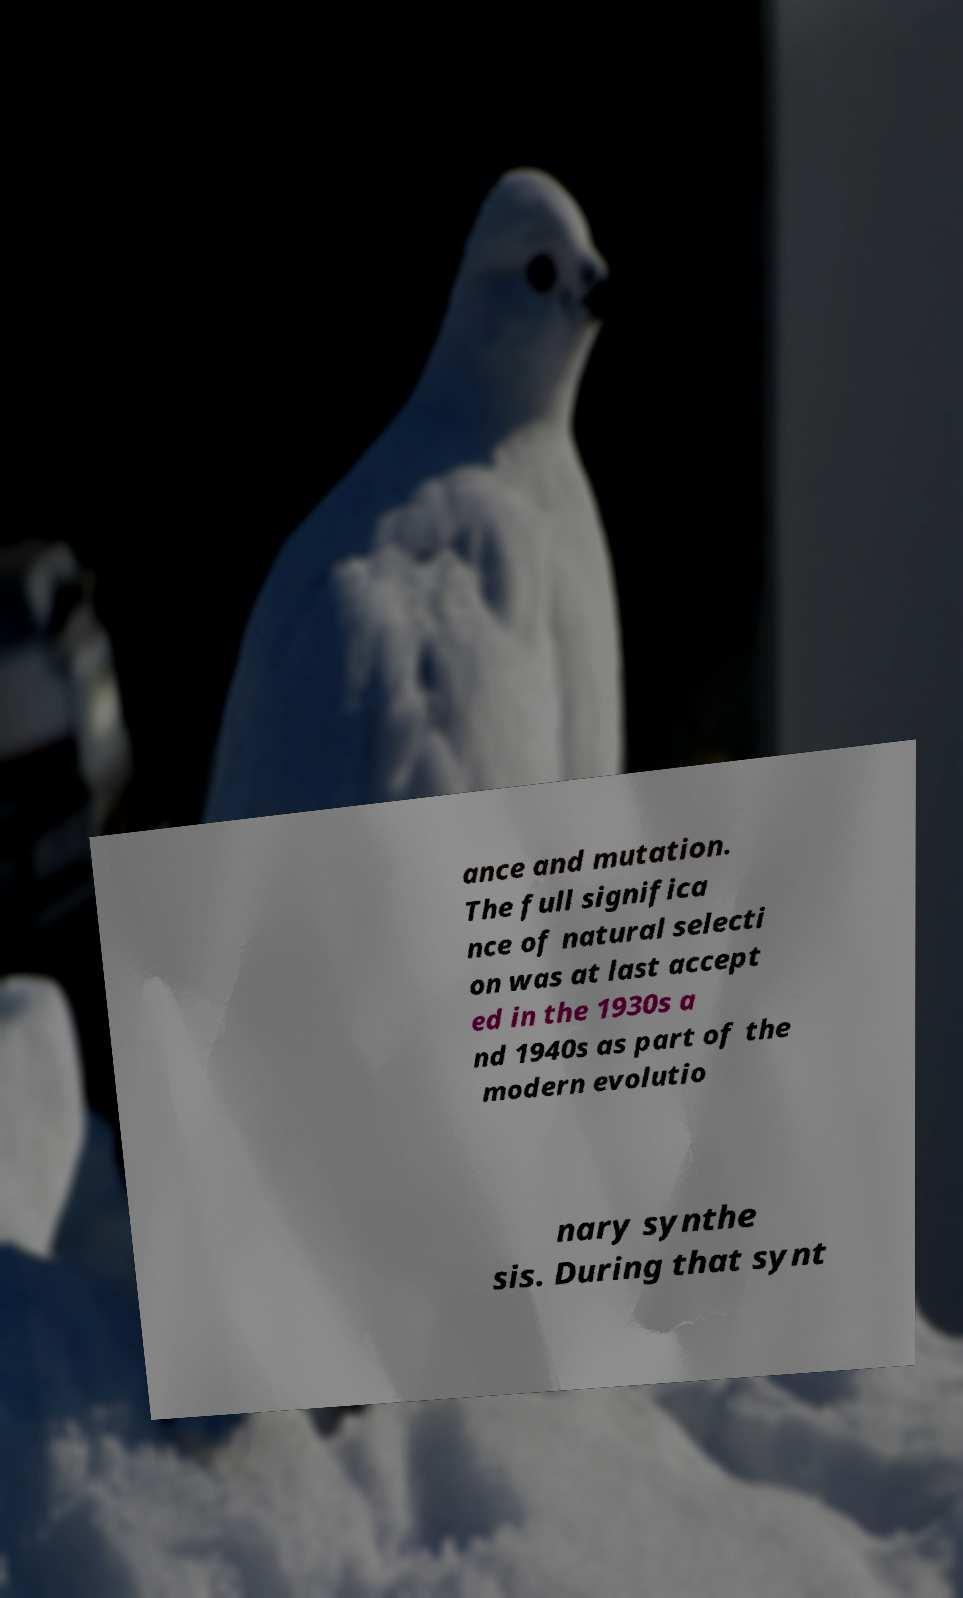Can you accurately transcribe the text from the provided image for me? ance and mutation. The full significa nce of natural selecti on was at last accept ed in the 1930s a nd 1940s as part of the modern evolutio nary synthe sis. During that synt 